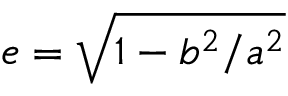Convert formula to latex. <formula><loc_0><loc_0><loc_500><loc_500>e = \sqrt { 1 - b ^ { 2 } / a ^ { 2 } }</formula> 